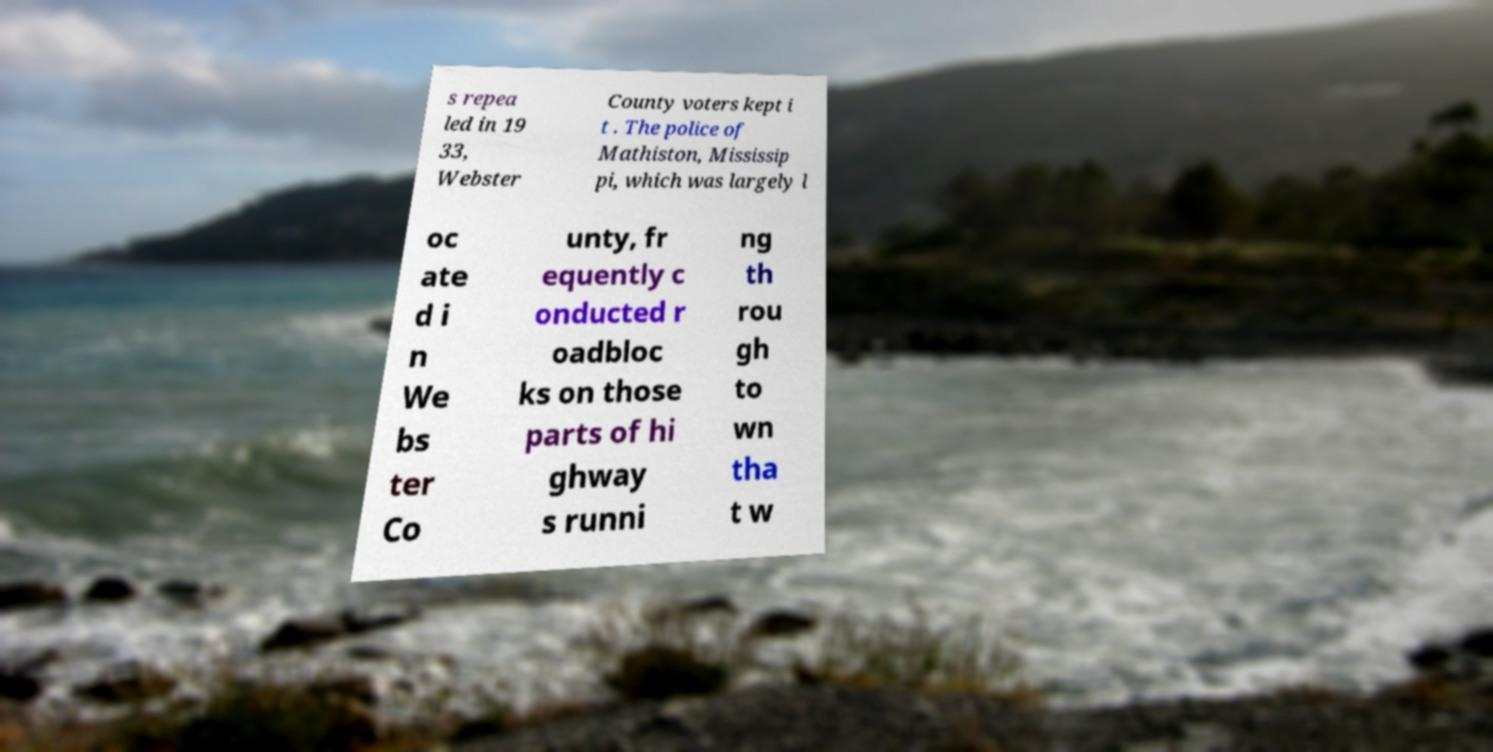There's text embedded in this image that I need extracted. Can you transcribe it verbatim? s repea led in 19 33, Webster County voters kept i t . The police of Mathiston, Mississip pi, which was largely l oc ate d i n We bs ter Co unty, fr equently c onducted r oadbloc ks on those parts of hi ghway s runni ng th rou gh to wn tha t w 